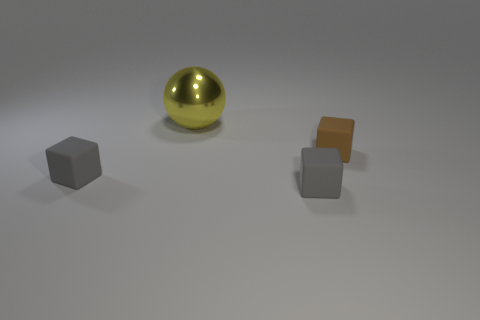Add 1 gray rubber things. How many objects exist? 5 Subtract all blocks. How many objects are left? 1 Add 4 large yellow shiny balls. How many large yellow shiny balls are left? 5 Add 2 large brown matte blocks. How many large brown matte blocks exist? 2 Subtract 0 purple blocks. How many objects are left? 4 Subtract all yellow metal balls. Subtract all shiny things. How many objects are left? 2 